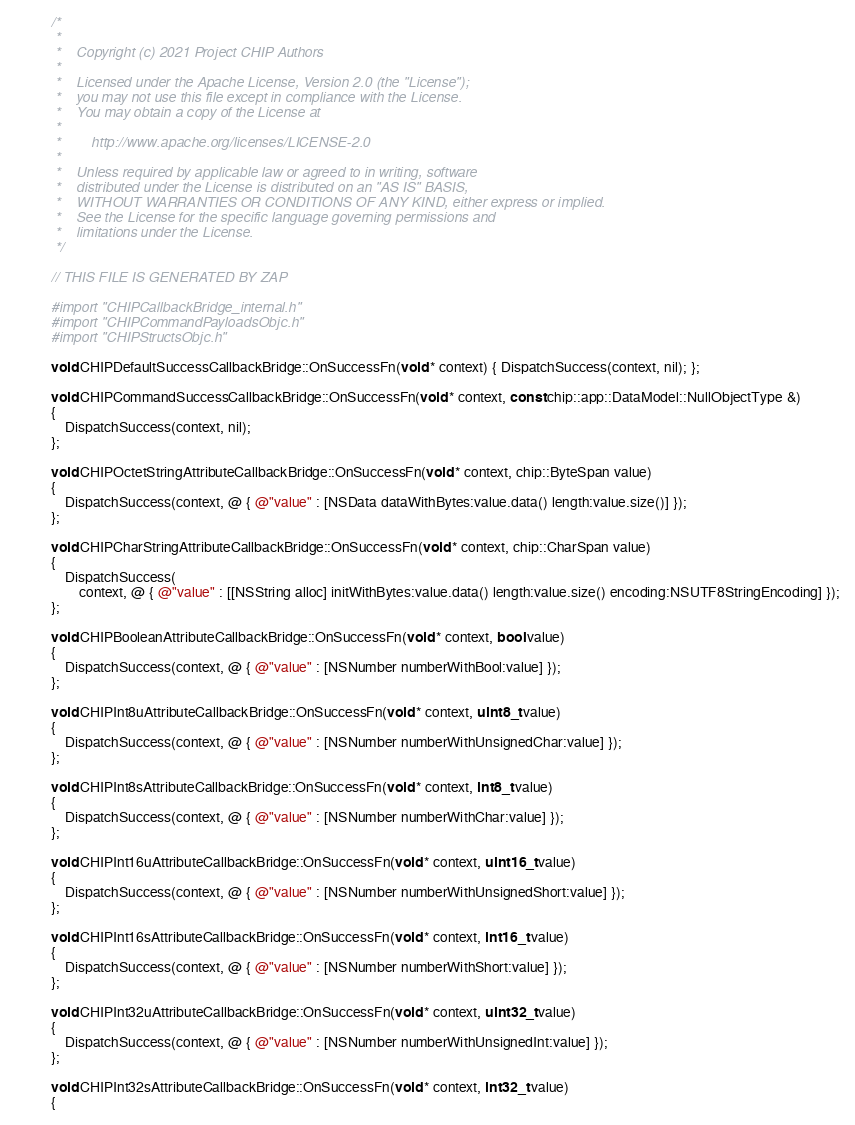Convert code to text. <code><loc_0><loc_0><loc_500><loc_500><_ObjectiveC_>/*
 *
 *    Copyright (c) 2021 Project CHIP Authors
 *
 *    Licensed under the Apache License, Version 2.0 (the "License");
 *    you may not use this file except in compliance with the License.
 *    You may obtain a copy of the License at
 *
 *        http://www.apache.org/licenses/LICENSE-2.0
 *
 *    Unless required by applicable law or agreed to in writing, software
 *    distributed under the License is distributed on an "AS IS" BASIS,
 *    WITHOUT WARRANTIES OR CONDITIONS OF ANY KIND, either express or implied.
 *    See the License for the specific language governing permissions and
 *    limitations under the License.
 */

// THIS FILE IS GENERATED BY ZAP

#import "CHIPCallbackBridge_internal.h"
#import "CHIPCommandPayloadsObjc.h"
#import "CHIPStructsObjc.h"

void CHIPDefaultSuccessCallbackBridge::OnSuccessFn(void * context) { DispatchSuccess(context, nil); };

void CHIPCommandSuccessCallbackBridge::OnSuccessFn(void * context, const chip::app::DataModel::NullObjectType &)
{
    DispatchSuccess(context, nil);
};

void CHIPOctetStringAttributeCallbackBridge::OnSuccessFn(void * context, chip::ByteSpan value)
{
    DispatchSuccess(context, @ { @"value" : [NSData dataWithBytes:value.data() length:value.size()] });
};

void CHIPCharStringAttributeCallbackBridge::OnSuccessFn(void * context, chip::CharSpan value)
{
    DispatchSuccess(
        context, @ { @"value" : [[NSString alloc] initWithBytes:value.data() length:value.size() encoding:NSUTF8StringEncoding] });
};

void CHIPBooleanAttributeCallbackBridge::OnSuccessFn(void * context, bool value)
{
    DispatchSuccess(context, @ { @"value" : [NSNumber numberWithBool:value] });
};

void CHIPInt8uAttributeCallbackBridge::OnSuccessFn(void * context, uint8_t value)
{
    DispatchSuccess(context, @ { @"value" : [NSNumber numberWithUnsignedChar:value] });
};

void CHIPInt8sAttributeCallbackBridge::OnSuccessFn(void * context, int8_t value)
{
    DispatchSuccess(context, @ { @"value" : [NSNumber numberWithChar:value] });
};

void CHIPInt16uAttributeCallbackBridge::OnSuccessFn(void * context, uint16_t value)
{
    DispatchSuccess(context, @ { @"value" : [NSNumber numberWithUnsignedShort:value] });
};

void CHIPInt16sAttributeCallbackBridge::OnSuccessFn(void * context, int16_t value)
{
    DispatchSuccess(context, @ { @"value" : [NSNumber numberWithShort:value] });
};

void CHIPInt32uAttributeCallbackBridge::OnSuccessFn(void * context, uint32_t value)
{
    DispatchSuccess(context, @ { @"value" : [NSNumber numberWithUnsignedInt:value] });
};

void CHIPInt32sAttributeCallbackBridge::OnSuccessFn(void * context, int32_t value)
{</code> 